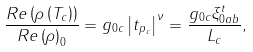<formula> <loc_0><loc_0><loc_500><loc_500>\frac { R e \left ( \rho \left ( T _ { c } \right ) \right ) } { R e \left ( \rho \right ) _ { 0 } } = g _ { 0 c } \left | t _ { p _ { c } } \right | ^ { \nu } = \frac { g _ { 0 c } \xi _ { 0 a b } ^ { t } } { L _ { c } } ,</formula> 